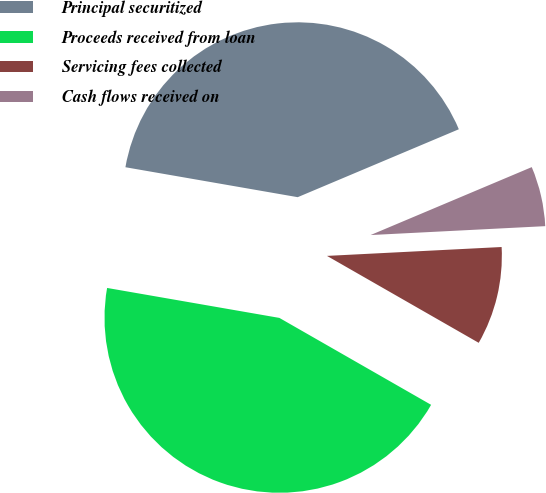Convert chart to OTSL. <chart><loc_0><loc_0><loc_500><loc_500><pie_chart><fcel>Principal securitized<fcel>Proceeds received from loan<fcel>Servicing fees collected<fcel>Cash flows received on<nl><fcel>40.91%<fcel>44.46%<fcel>9.09%<fcel>5.54%<nl></chart> 